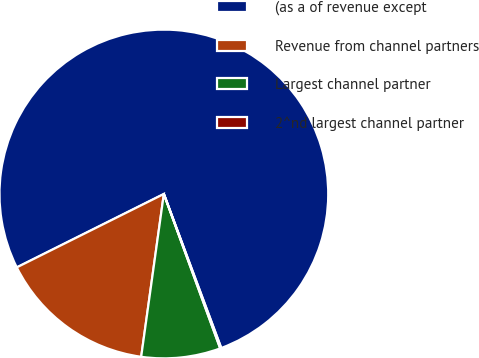Convert chart. <chart><loc_0><loc_0><loc_500><loc_500><pie_chart><fcel>(as a of revenue except<fcel>Revenue from channel partners<fcel>Largest channel partner<fcel>2^nd largest channel partner<nl><fcel>76.69%<fcel>15.43%<fcel>7.77%<fcel>0.11%<nl></chart> 